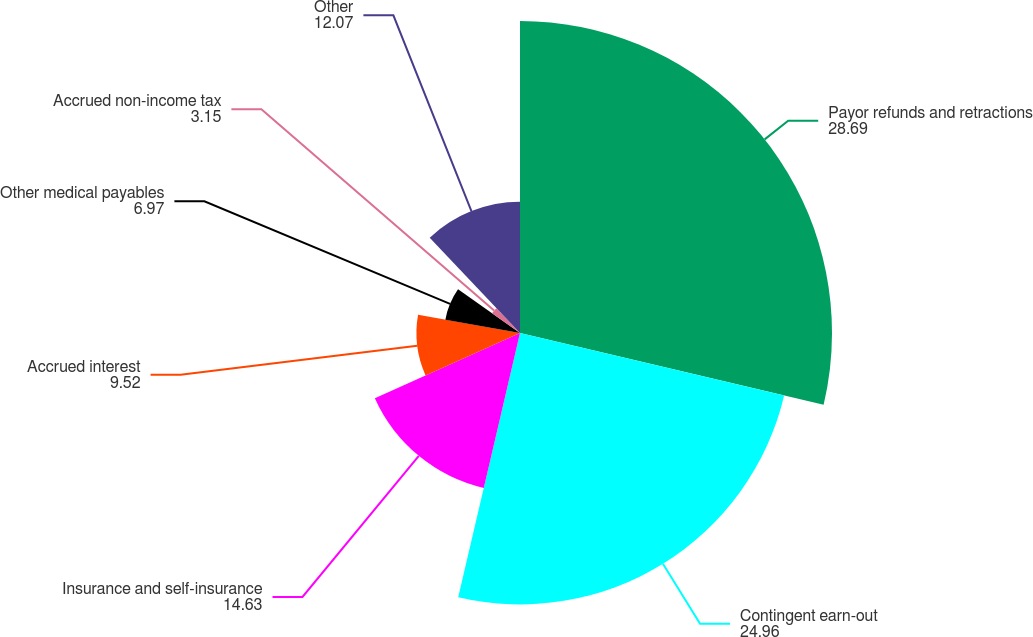Convert chart. <chart><loc_0><loc_0><loc_500><loc_500><pie_chart><fcel>Payor refunds and retractions<fcel>Contingent earn-out<fcel>Insurance and self-insurance<fcel>Accrued interest<fcel>Other medical payables<fcel>Accrued non-income tax<fcel>Other<nl><fcel>28.69%<fcel>24.96%<fcel>14.63%<fcel>9.52%<fcel>6.97%<fcel>3.15%<fcel>12.07%<nl></chart> 